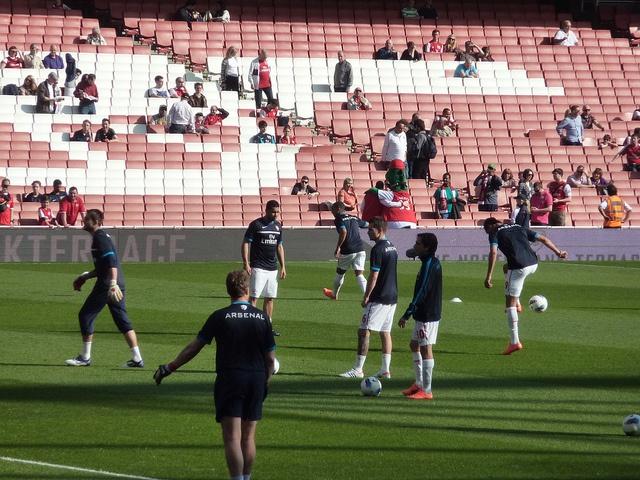Describe the objects in this image and their specific colors. I can see people in black, lightpink, white, and gray tones, chair in black, white, lightpink, darkgray, and gray tones, people in black, gray, and darkgreen tones, people in black, gray, and darkgreen tones, and people in black, gray, lightgray, and darkgray tones in this image. 